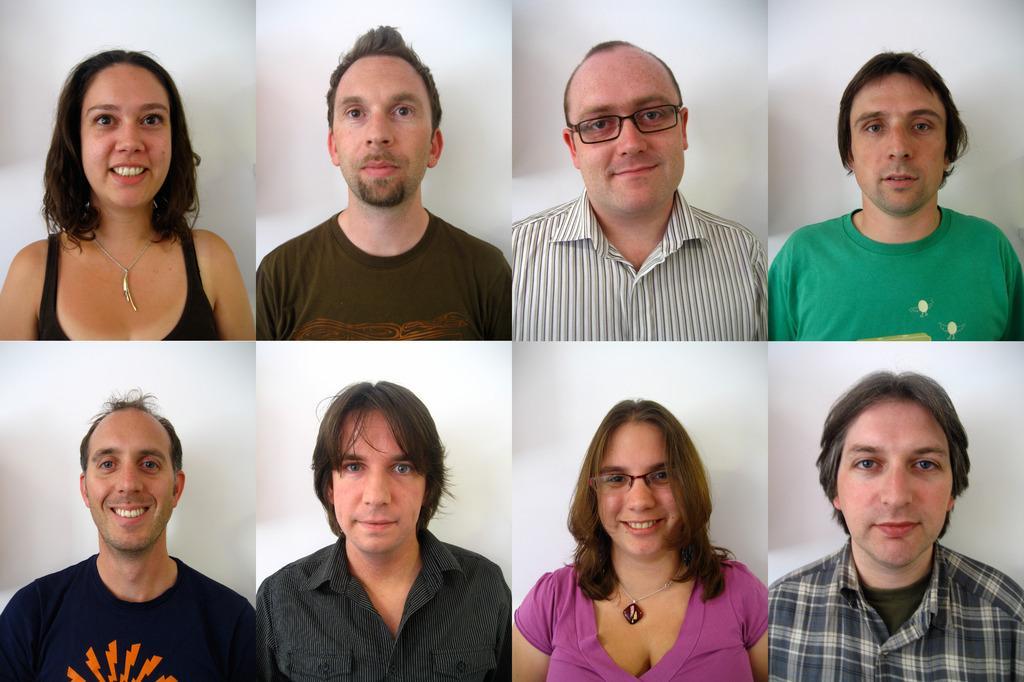Please provide a concise description of this image. In this picture I can see there are some different people, all are smiling and these two people have spectacles and in the backdrop there is a white surface. 